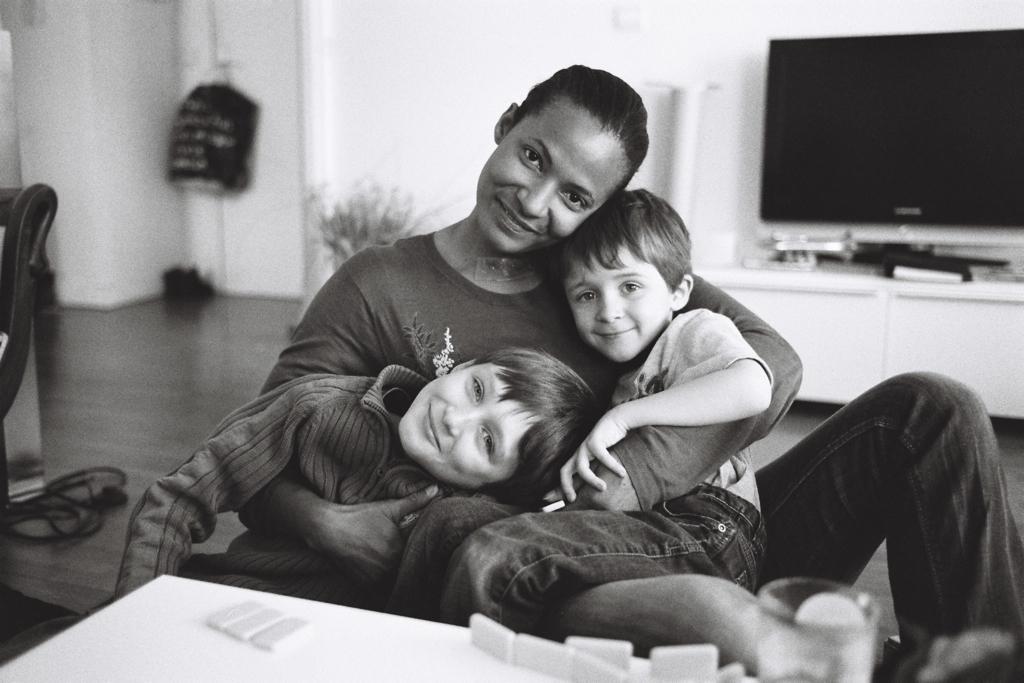Could you give a brief overview of what you see in this image? In the image I can see a woman and two boys in the middle of the image. There is a smile on their faces. I can see a table at the bottom of the picture. I can see a television on the top right side. There is a wooden drawer on the floor and is on the right side. 